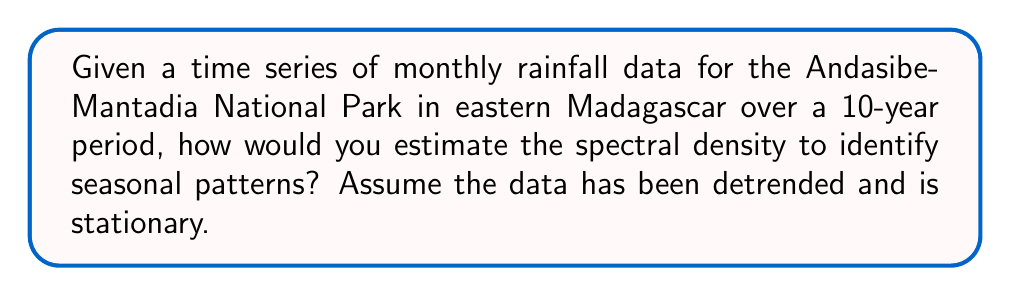Solve this math problem. To estimate the spectral density of the rainfall time series, we can follow these steps:

1. Compute the sample autocovariance function:
   $$\hat{\gamma}(h) = \frac{1}{n} \sum_{t=1}^{n-h} (x_t - \bar{x})(x_{t+h} - \bar{x})$$
   where $x_t$ is the rainfall at time $t$, $\bar{x}$ is the mean, and $h$ is the lag.

2. Choose a spectral window (e.g., Bartlett window):
   $$w(h) = \begin{cases}
   1 - \frac{|h|}{m}, & |h| \leq m \\
   0, & |h| > m
   \end{cases}$$
   where $m$ is the truncation point (e.g., $m = \sqrt{n}$).

3. Estimate the spectral density using the smoothed periodogram:
   $$\hat{f}(\omega) = \frac{1}{2\pi} \sum_{h=-(n-1)}^{n-1} w(h)\hat{\gamma}(h)e^{-ih\omega}$$
   for frequencies $\omega \in [-\pi, \pi]$.

4. Evaluate $\hat{f}(\omega)$ at a grid of frequencies, typically:
   $$\omega_j = \frac{2\pi j}{n}, j = 0, 1, ..., \lfloor n/2 \rfloor$$

5. Plot the estimated spectral density against the frequencies to identify peaks corresponding to seasonal patterns.

6. For rainfall data in Madagascar, we expect to see peaks at frequencies corresponding to the annual cycle (period of 12 months) and potentially the monsoon seasons.
Answer: Compute sample autocovariance, apply spectral window, estimate spectral density using smoothed periodogram, evaluate at frequency grid, plot and identify peaks. 